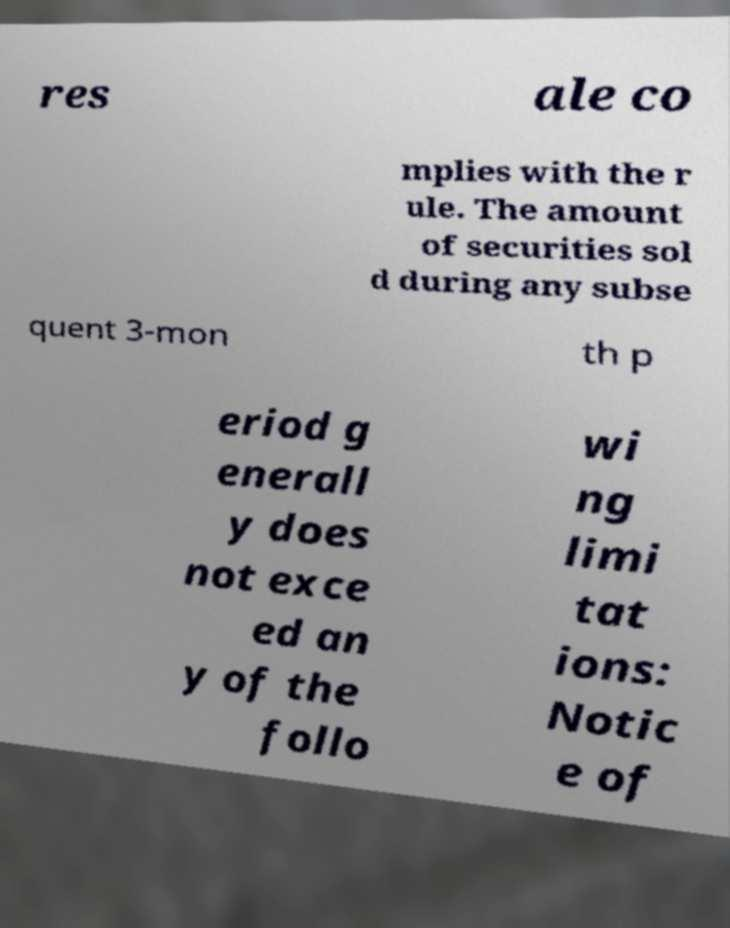I need the written content from this picture converted into text. Can you do that? res ale co mplies with the r ule. The amount of securities sol d during any subse quent 3-mon th p eriod g enerall y does not exce ed an y of the follo wi ng limi tat ions: Notic e of 